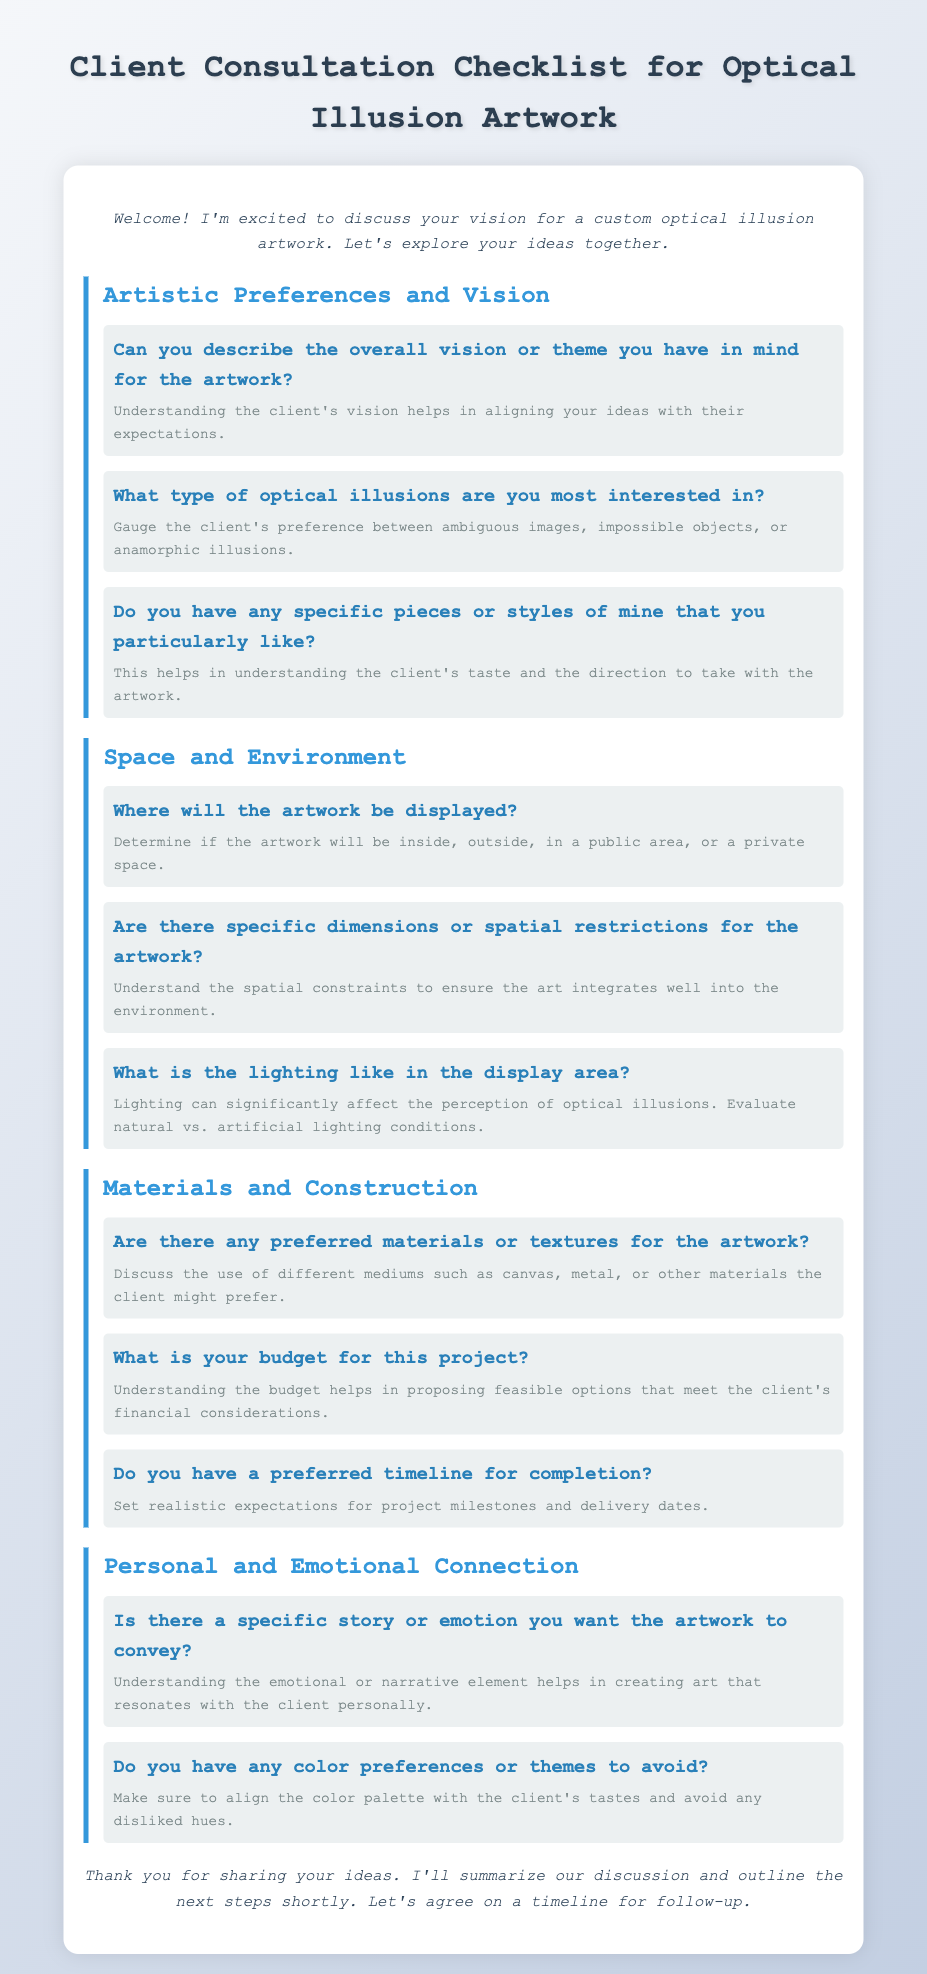What is the title of the document? The title is provided in the opening of the document, which clearly states its purpose for consulting clients about artwork.
Answer: Client Consultation Checklist for Optical Illusion Artwork What is the first question listed under Artistic Preferences and Vision? The first question is aimed at understanding the client's overall vision, which is vital in guiding the creation process.
Answer: Can you describe the overall vision or theme you have in mind for the artwork? How many sections are in the checklist? The document is organized into multiple sections, each addressing a specific aspect of the client consultation.
Answer: Four What is the last question in the Materials and Construction section? This question relates to the timeline for completion, reflecting on project management and client expectations.
Answer: Do you have a preferred timeline for completion? What color is used for the section header text? The color used for the section headers is essential to understanding the visual style and organization of the document.
Answer: #3498db How does the document describe the importance of lighting? The document discusses lighting in the context of how it affects the perception of optical illusions, emphasizing importance in design.
Answer: Lighting can significantly affect the perception of optical illusions What is the primary emotional component that clients are asked about? Understanding the emotional connection is crucial for creating personalized art, which is covered in the questions.
Answer: Is there a specific story or emotion you want the artwork to convey? Are there any questions about color preferences? The checklist addresses the client's preferences for colors explicitly, ensuring their tastes are honored in the artwork.
Answer: Do you have any color preferences or themes to avoid? 